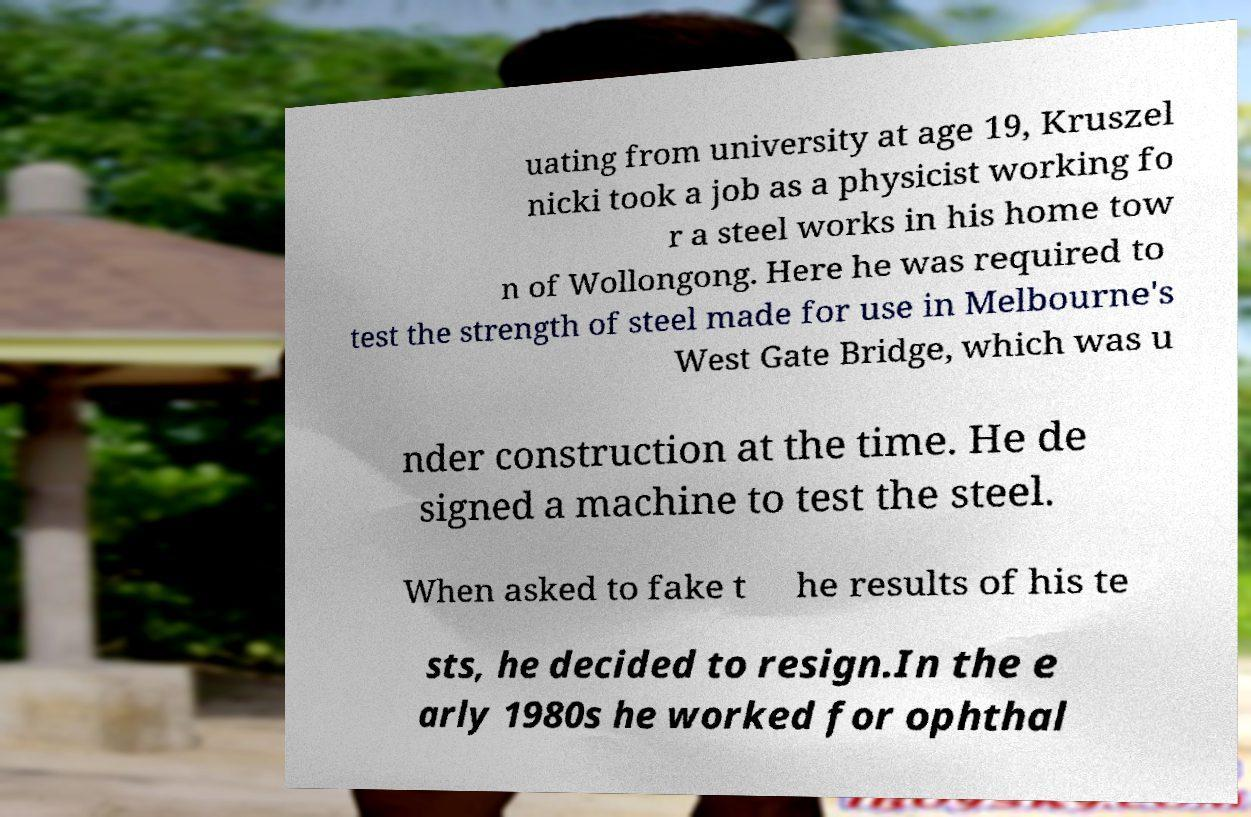There's text embedded in this image that I need extracted. Can you transcribe it verbatim? uating from university at age 19, Kruszel nicki took a job as a physicist working fo r a steel works in his home tow n of Wollongong. Here he was required to test the strength of steel made for use in Melbourne's West Gate Bridge, which was u nder construction at the time. He de signed a machine to test the steel. When asked to fake t he results of his te sts, he decided to resign.In the e arly 1980s he worked for ophthal 